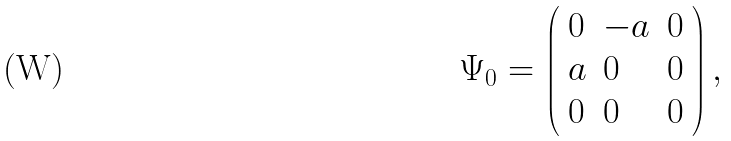Convert formula to latex. <formula><loc_0><loc_0><loc_500><loc_500>\Psi _ { 0 } = \left ( \begin{array} { l l l } { 0 } & { - a } & { 0 } \\ { a } & { 0 } & { 0 } \\ { 0 } & { 0 } & { 0 } \end{array} \right ) ,</formula> 